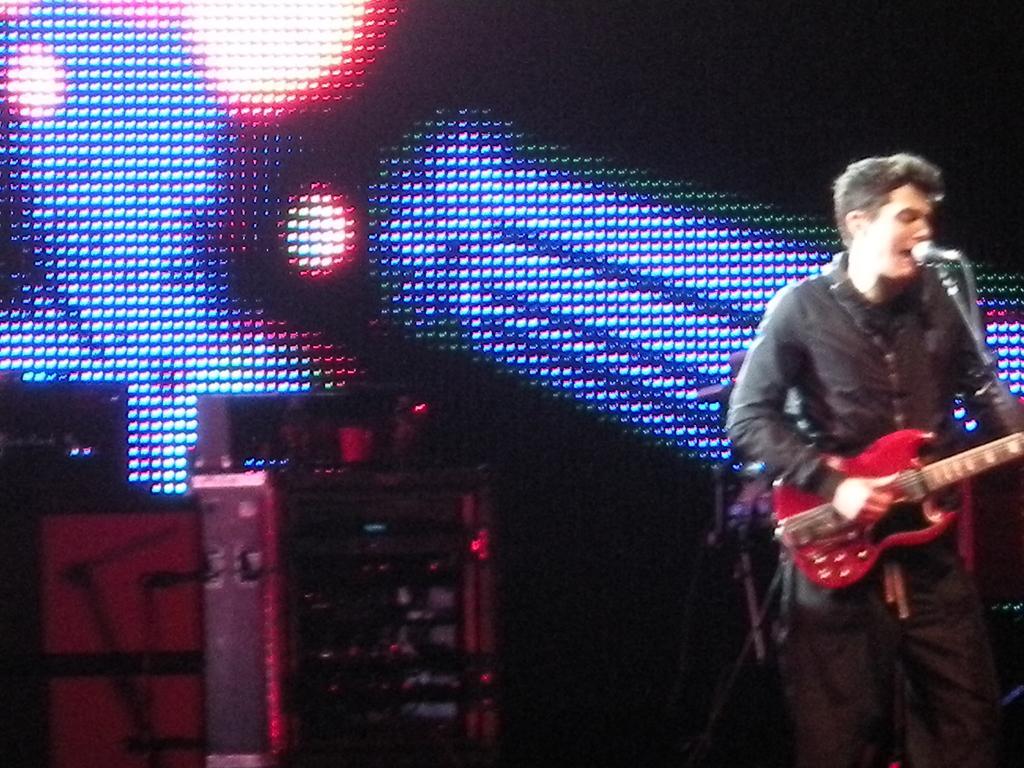Describe this image in one or two sentences. In this image on the right side there is one man who is playing guitar. In front of him there is one mike, it seems that he is singing. On the background there is a screen and some lights are there and on the left side there are some sound systems. 